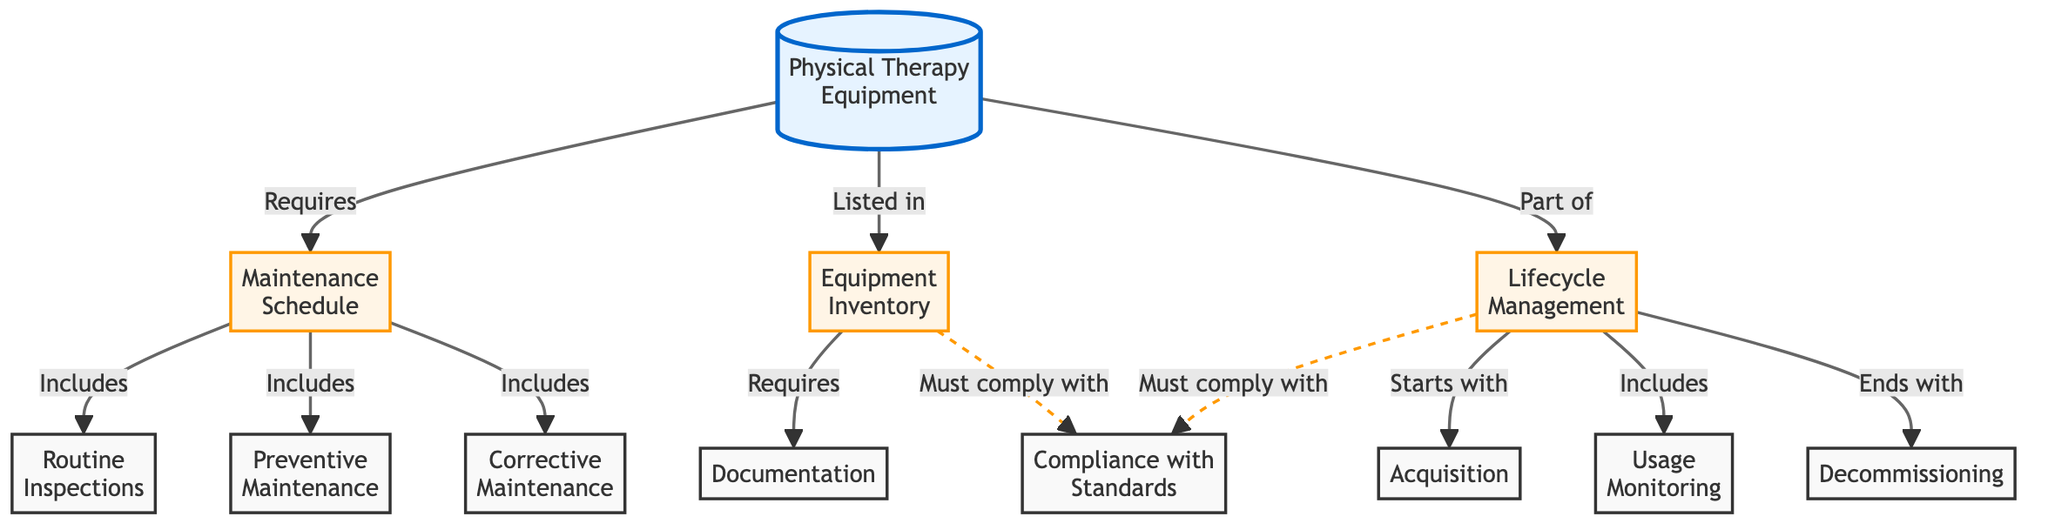What are the three types of maintenance included in the maintenance schedule? The maintenance schedule includes three types of maintenance: Routine Inspections, Preventive Maintenance, and Corrective Maintenance, as indicated by the arrows leading from the Maintenance Schedule node.
Answer: Routine Inspections, Preventive Maintenance, Corrective Maintenance How many nodes are directly connected to the 'Physical Therapy Equipment'? The 'Physical Therapy Equipment' node has four direct connections: 'Maintenance Schedule', 'Equipment Inventory', and 'Lifecycle Management'. Counting these gives a total of four nodes connected to it.
Answer: 4 What must the equipment inventory comply with? The equipment inventory must comply with standards, as indicated by the dashed line linking it to the 'Compliance with Standards' node.
Answer: Compliance with Standards What starts the lifecycle management process? The lifecycle management process starts with acquisition, as shown by the arrow leading from the 'Lifecycle Management' node to 'Acquisition'.
Answer: Acquisition What ends the lifecycle management process? The lifecycle management process ends with decommissioning, which is indicated by the arrow from the 'Lifecycle Management' node to the 'Decommissioning' node.
Answer: Decommissioning Which part of the diagram includes 'Documentation'? 'Documentation' is included under the 'Equipment Inventory' section as it is directly connected to it, indicating that it is a requirement of the equipment inventory.
Answer: Equipment Inventory How many components are listed under the 'Maintenance Schedule'? There are three main components listed under the 'Maintenance Schedule', which are Routine Inspections, Preventive Maintenance, and Corrective Maintenance. Thus, the count is three.
Answer: 3 What links the 'Lifecycle Management' to 'Usage Monitoring'? The link between the 'Lifecycle Management' and 'Usage Monitoring' nodes is characterized as "Includes", as seen in the diagram.
Answer: Includes What is the relationship between 'Compliance with Standards' and both 'Equipment Inventory' and 'Lifecycle Management'? Both 'Equipment Inventory' and 'Lifecycle Management' must comply with standards, denoted by the dashed lines pointing from both these nodes to the 'Compliance with Standards' node.
Answer: Must comply with 